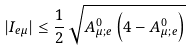Convert formula to latex. <formula><loc_0><loc_0><loc_500><loc_500>| I _ { e \mu } | \leq \frac { 1 } { 2 } \, \sqrt { A _ { \mu ; e } ^ { 0 } \left ( 4 - A _ { \mu ; e } ^ { 0 } \right ) }</formula> 